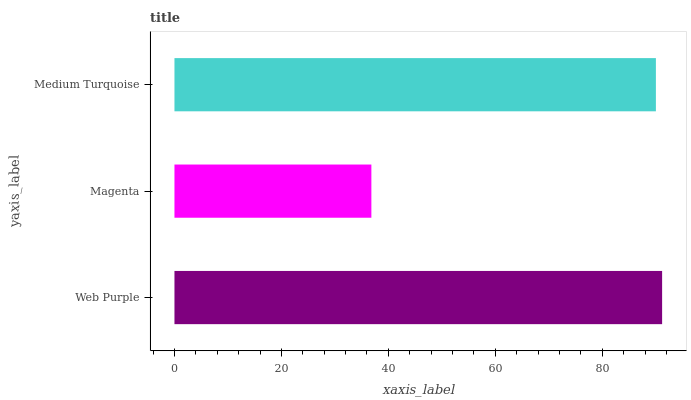Is Magenta the minimum?
Answer yes or no. Yes. Is Web Purple the maximum?
Answer yes or no. Yes. Is Medium Turquoise the minimum?
Answer yes or no. No. Is Medium Turquoise the maximum?
Answer yes or no. No. Is Medium Turquoise greater than Magenta?
Answer yes or no. Yes. Is Magenta less than Medium Turquoise?
Answer yes or no. Yes. Is Magenta greater than Medium Turquoise?
Answer yes or no. No. Is Medium Turquoise less than Magenta?
Answer yes or no. No. Is Medium Turquoise the high median?
Answer yes or no. Yes. Is Medium Turquoise the low median?
Answer yes or no. Yes. Is Web Purple the high median?
Answer yes or no. No. Is Web Purple the low median?
Answer yes or no. No. 